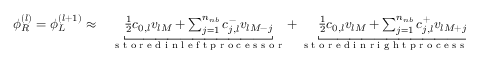<formula> <loc_0><loc_0><loc_500><loc_500>\begin{array} { r l } { \phi _ { R } ^ { ( l ) } = \phi _ { L } ^ { ( l + 1 ) } \approx } & \underbracket { \frac { 1 } { 2 } c _ { 0 , l } v _ { l M } + \sum _ { j = 1 } ^ { n _ { n b } } c _ { j , l } ^ { - } v _ { l M - j } } _ { s t o r e d i n l e f t p r o c e s s o r } + \underbracket { \frac { 1 } { 2 } c _ { 0 , l } v _ { l M } + \sum _ { j = 1 } ^ { n _ { n b } } c _ { j , l } ^ { + } v _ { l M + j } } _ { s t o r e d i n r i g h t p r o c e s s o r } , } \end{array}</formula> 